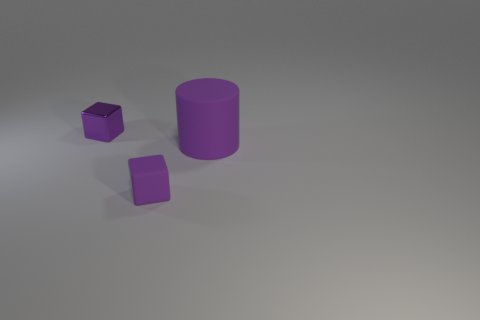The rubber cylinder that is the same color as the small rubber object is what size?
Provide a succinct answer. Large. There is a small thing that is behind the tiny matte object; does it have the same shape as the large rubber object?
Your answer should be compact. No. Are there more large objects that are behind the big purple matte object than metallic blocks that are behind the small purple metal thing?
Offer a very short reply. No. There is a small thing in front of the big purple thing; what number of tiny purple matte things are in front of it?
Your answer should be very brief. 0. What material is the other block that is the same color as the tiny rubber cube?
Your answer should be very brief. Metal. How many other objects are there of the same color as the matte cylinder?
Keep it short and to the point. 2. The tiny cube that is to the right of the tiny block on the left side of the small rubber cube is what color?
Your answer should be compact. Purple. Are there any other small shiny blocks that have the same color as the tiny shiny block?
Make the answer very short. No. How many matte objects are purple cubes or small cylinders?
Offer a terse response. 1. Are there any big cyan balls made of the same material as the large object?
Your answer should be very brief. No. 